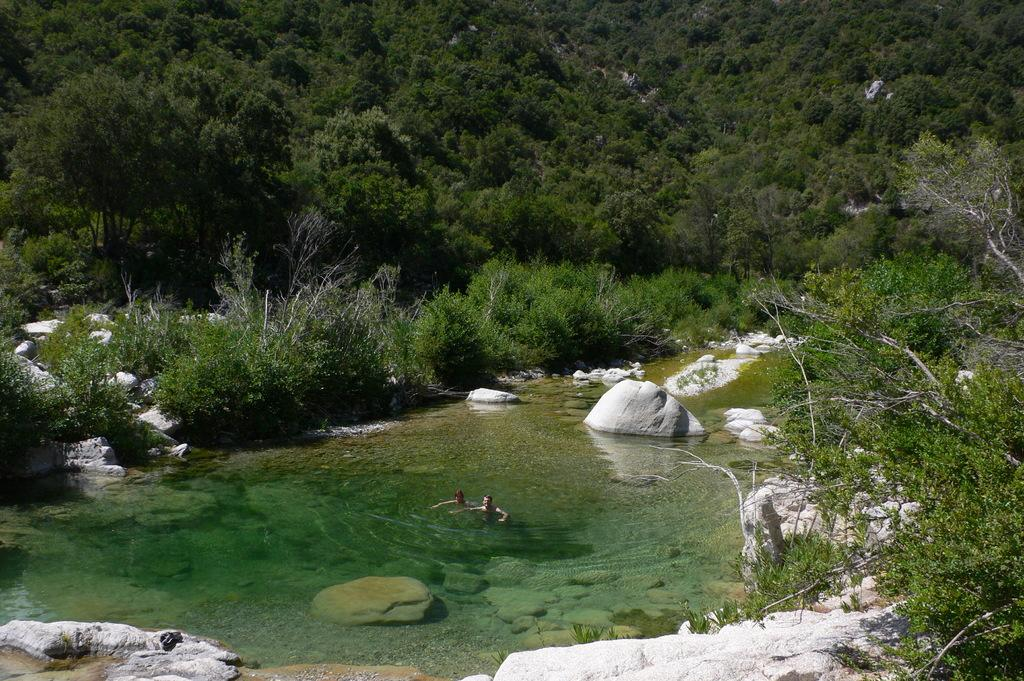What is located in the foreground of the image? There are stones and trees in the foreground of the image. What are the two persons in the image doing? The two persons are in the water in the middle of the image. What can be seen in the background of the image? There is greenery in the background of the image. What type of reward can be seen hanging from the trees in the image? There is no reward visible in the image; the trees are in the foreground with stones. How many things are present in the water with the two persons? The question is unclear as it does not specify what "things" are being referred to. However, there are no additional objects mentioned in the image besides the two persons in the water. 